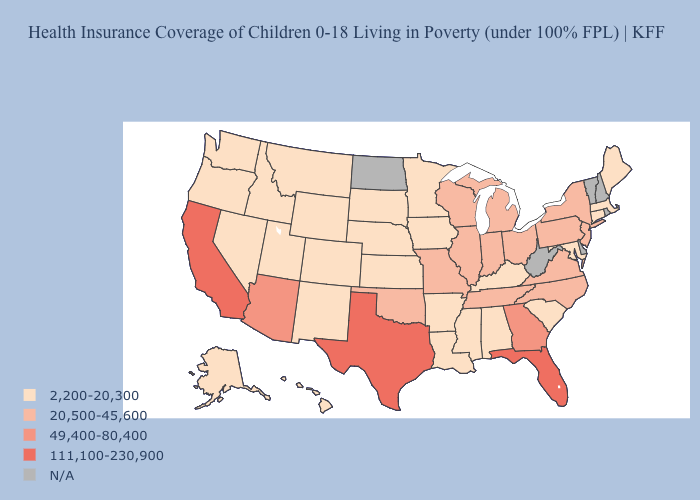What is the highest value in states that border Iowa?
Be succinct. 20,500-45,600. What is the lowest value in the USA?
Answer briefly. 2,200-20,300. What is the value of Louisiana?
Be succinct. 2,200-20,300. Which states have the highest value in the USA?
Answer briefly. California, Florida, Texas. What is the value of Massachusetts?
Quick response, please. 2,200-20,300. Does Idaho have the highest value in the USA?
Write a very short answer. No. Name the states that have a value in the range N/A?
Keep it brief. Delaware, New Hampshire, North Dakota, Rhode Island, Vermont, West Virginia. What is the lowest value in states that border Mississippi?
Short answer required. 2,200-20,300. Does Texas have the highest value in the USA?
Concise answer only. Yes. Does Massachusetts have the highest value in the Northeast?
Give a very brief answer. No. How many symbols are there in the legend?
Give a very brief answer. 5. What is the highest value in the MidWest ?
Give a very brief answer. 20,500-45,600. Name the states that have a value in the range 111,100-230,900?
Concise answer only. California, Florida, Texas. 